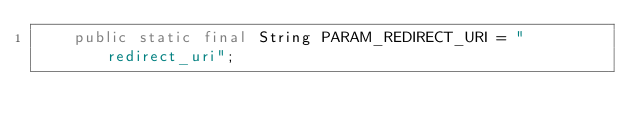<code> <loc_0><loc_0><loc_500><loc_500><_Java_>    public static final String PARAM_REDIRECT_URI = "redirect_uri";</code> 